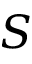<formula> <loc_0><loc_0><loc_500><loc_500>S</formula> 